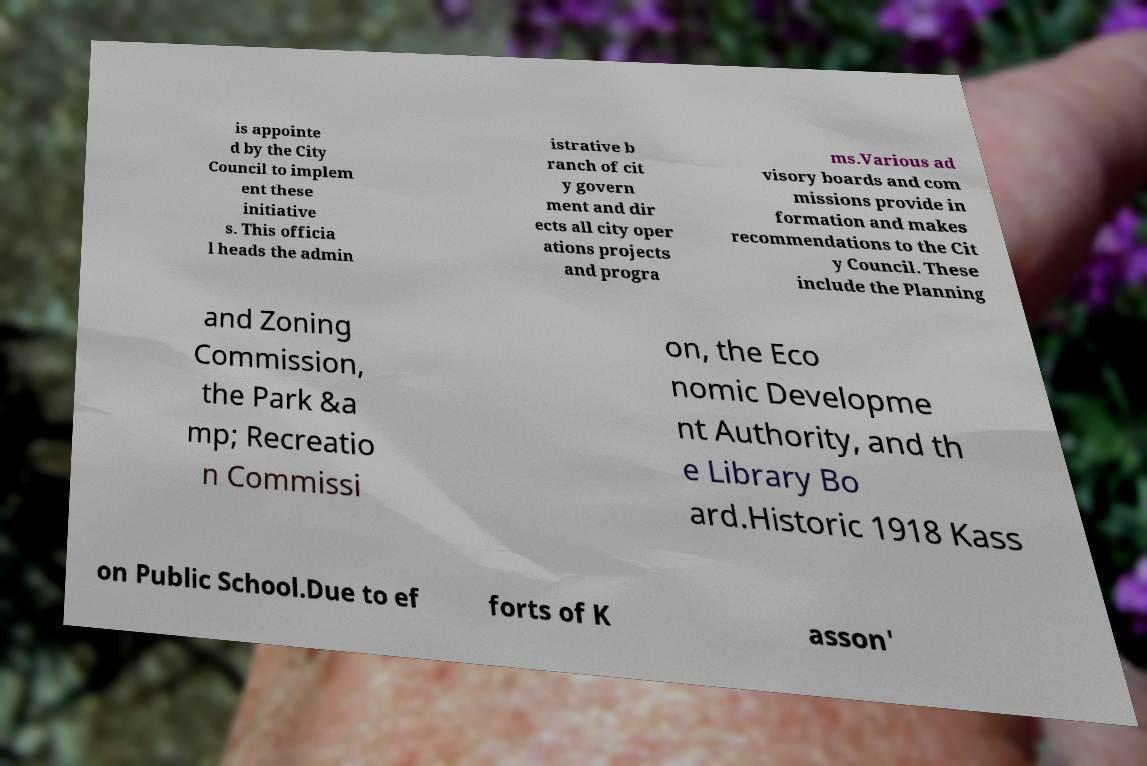Please identify and transcribe the text found in this image. is appointe d by the City Council to implem ent these initiative s. This officia l heads the admin istrative b ranch of cit y govern ment and dir ects all city oper ations projects and progra ms.Various ad visory boards and com missions provide in formation and makes recommendations to the Cit y Council. These include the Planning and Zoning Commission, the Park &a mp; Recreatio n Commissi on, the Eco nomic Developme nt Authority, and th e Library Bo ard.Historic 1918 Kass on Public School.Due to ef forts of K asson' 